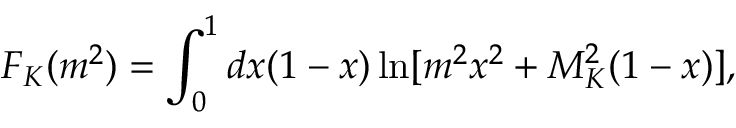Convert formula to latex. <formula><loc_0><loc_0><loc_500><loc_500>F _ { K } ( m ^ { 2 } ) = \int _ { 0 } ^ { 1 } d x ( 1 - x ) \ln [ m ^ { 2 } x ^ { 2 } + M _ { K } ^ { 2 } ( 1 - x ) ] ,</formula> 